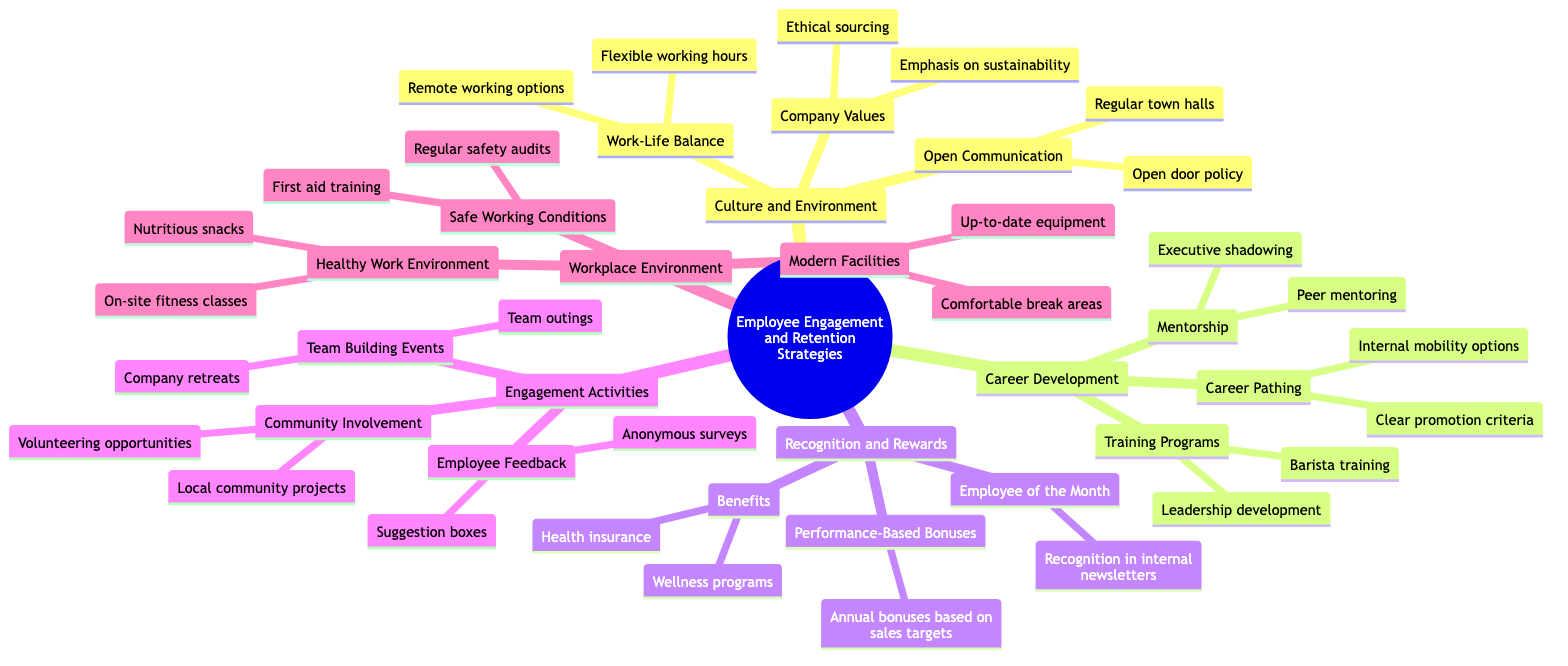What is one aspect of work-life balance mentioned in the diagram? The node "Work-Life Balance" under "Culture and Environment" provides "Flexible working hours" as one aspect. This information is directly derived from examining the node for work-life balance.
Answer: Flexible working hours How many main categories are there under Employee Engagement and Retention Strategies? By counting the nodes directly connected to the root node, we find there are five main categories: Culture and Environment, Career Development, Recognition and Rewards, Engagement Activities, and Workplace Environment.
Answer: 5 What type of training is offered under Training Programs? Under "Training Programs" in "Career Development," "Barista training" is specifically mentioned, showcasing a focus on skill development for roles within the company.
Answer: Barista training Which recognition strategy includes "Annual bonuses based on sales targets"? "Performance-Based Bonuses" is a specific recognition strategy under the "Recognition and Rewards" category, which includes "Annual bonuses based on sales targets." The location on the map helps in identifying it easily.
Answer: Performance-Based Bonuses What is a method of employee feedback mentioned in the diagram? The diagram lists "Anonymous surveys" as a method under "Employee Feedback" in the "Engagement Activities" category, indicating a strategy for gathering employee opinions.
Answer: Anonymous surveys How does the diagram depict the relationship between "Community Involvement" and "Engagement Activities"? "Community Involvement" is a sub-node under "Engagement Activities," showing that it is one of the methods used to enhance engagement among employees. This relationship can be established by tracing the hierarchy from the main category to the sub-category.
Answer: Sub-node What is emphasized in the company's values according to the diagram? The node titled "Company Values" under "Culture and Environment" includes "Emphasis on sustainability," indicating the company's commitment to sustainability practices as a core value.
Answer: Emphasis on sustainability Which category includes "On-site fitness classes"? "On-site fitness classes" fall under the "Healthy Work Environment" in the "Workplace Environment" category, demonstrating a focus on promoting health among employees. This node is nested under the larger category, making it easy to find.
Answer: Healthy Work Environment How many engagement activities are listed in the diagram? There are three engagement activities mentioned: Team Building Events, Employee Feedback, and Community Involvement. These are the primary subdivisions under the category Engagement Activities.
Answer: 3 